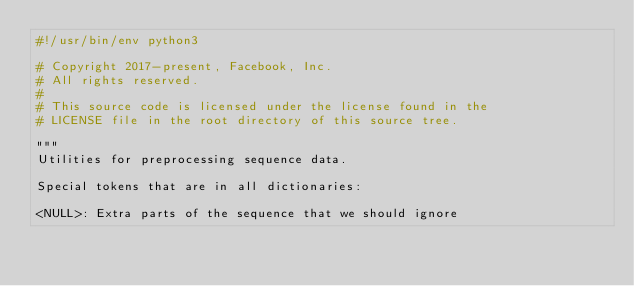Convert code to text. <code><loc_0><loc_0><loc_500><loc_500><_Python_>#!/usr/bin/env python3

# Copyright 2017-present, Facebook, Inc.
# All rights reserved.
#
# This source code is licensed under the license found in the
# LICENSE file in the root directory of this source tree.

"""
Utilities for preprocessing sequence data.

Special tokens that are in all dictionaries:

<NULL>: Extra parts of the sequence that we should ignore</code> 